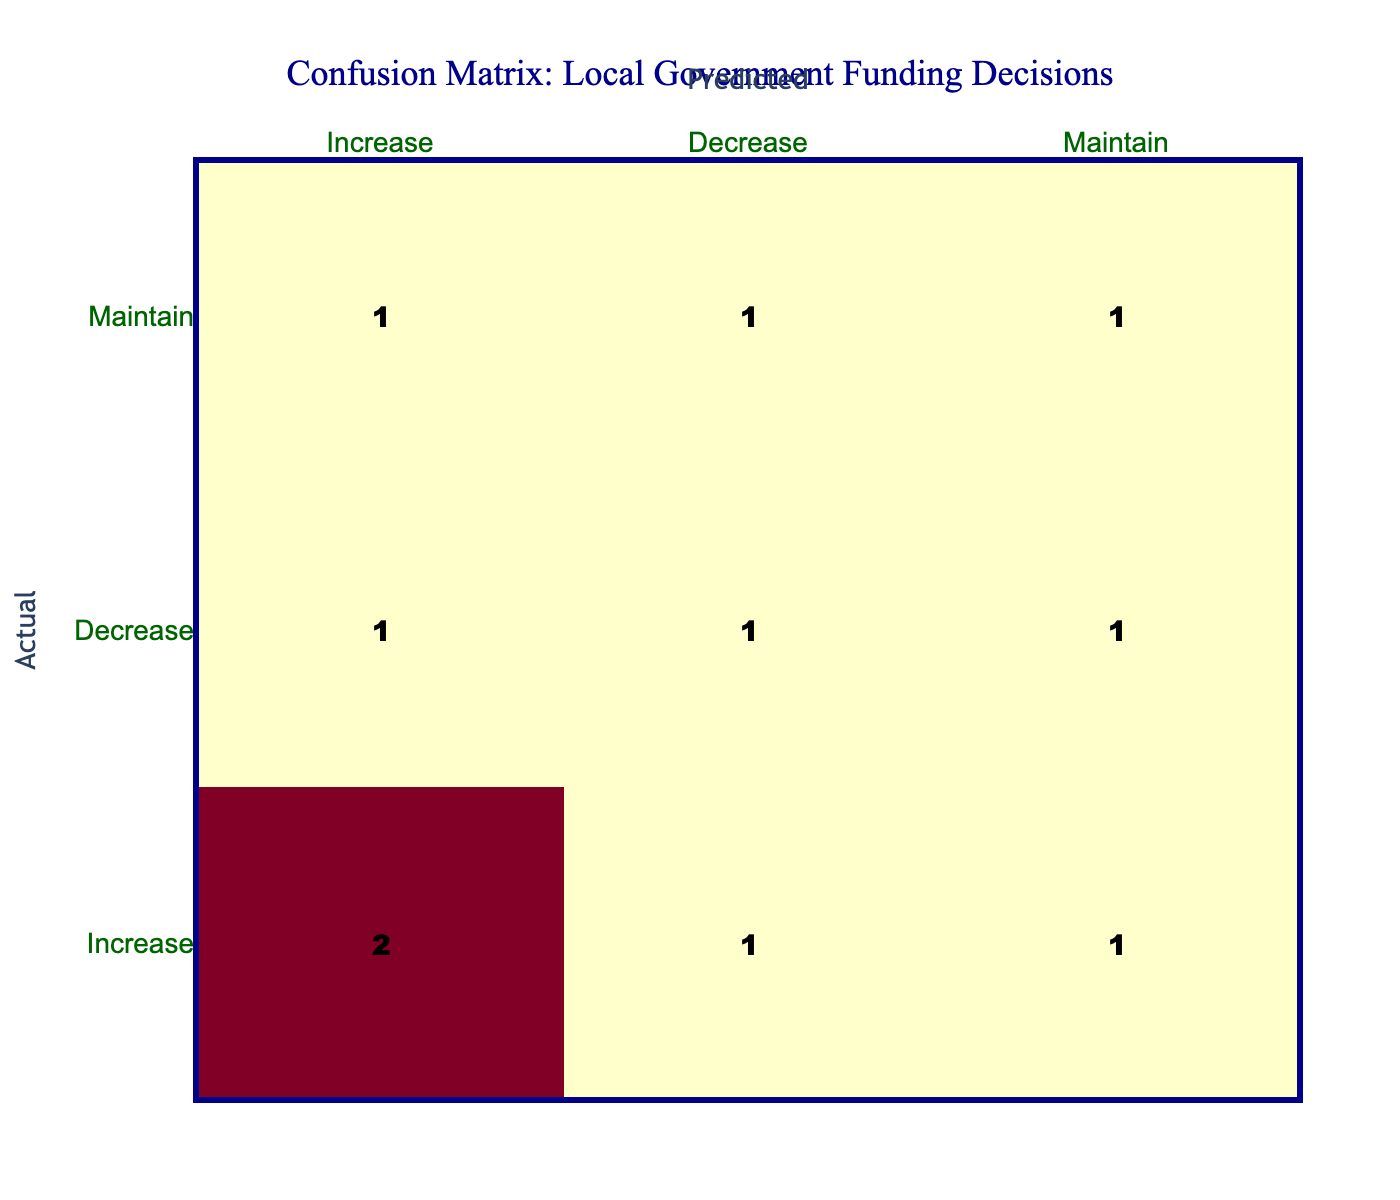What is the total number of times the funding decision was predicted to "Increase"? Looking at the predicted funding decision column, I can count the occurrences of "Increase." These are found in the second and sixth rows, as well as the first and ninth rows. Thus, the total is 5 occurrences of "Increase."
Answer: 5 How many actual "Maintain" funding decisions were incorrectly predicted as "Decrease"? To find the answer, look at the "Maintain" row in the actual funding decisions. The predicted decisions in this row indicate 1 incorrect prediction as "Decrease."
Answer: 1 Which funding decision had the highest count of accurate predictions? Reviewing the table, the counts for accurate predictions (where actual and predicted match) are: "Increase" (3), "Decrease" (1), "Maintain" (2). Here, "Increase" has the highest count with 3 accurate predictions.
Answer: Increase What percentage of actual "Decrease" funding decisions were predicted correctly? First, note the actual "Decrease" cases; there are 3 (found in rows 2, 4, and 8). Out of these, only 1 was accurately predicted as "Decrease." Therefore, the percentage is (1 correct / 3 actual) x 100 = 33.33%.
Answer: 33.33% Is there any funding decision that was never predicted accurately? By examining the confusion matrix, I can see that "Decrease" had 1 accurate prediction and the other decisions also had at least one correct prediction. Therefore, there are no funding decisions that were never predicted accurately.
Answer: No What is the total number of incorrect predictions for the "Maintain" decision? Looking at the "Maintain" row in the table, there are 3 incorrect predictions: one is predicted as "Increase" and two as "Decrease." So, the total is 3 incorrect predictions for "Maintain."
Answer: 3 How many funding decisions were predicted as "Maintain" when they were actual "Increase"? Checking the actual "Increase" row, it shows that there were 1 instances predicted as "Maintain."
Answer: 1 What is the ratio of correct predictions to incorrect predictions for the "Increase" decision? First, I find that there are 3 correct predictions (where actual equals predicted) for "Increase" and 2 incorrect predictions. The ratio is 3:2.
Answer: 3:2 